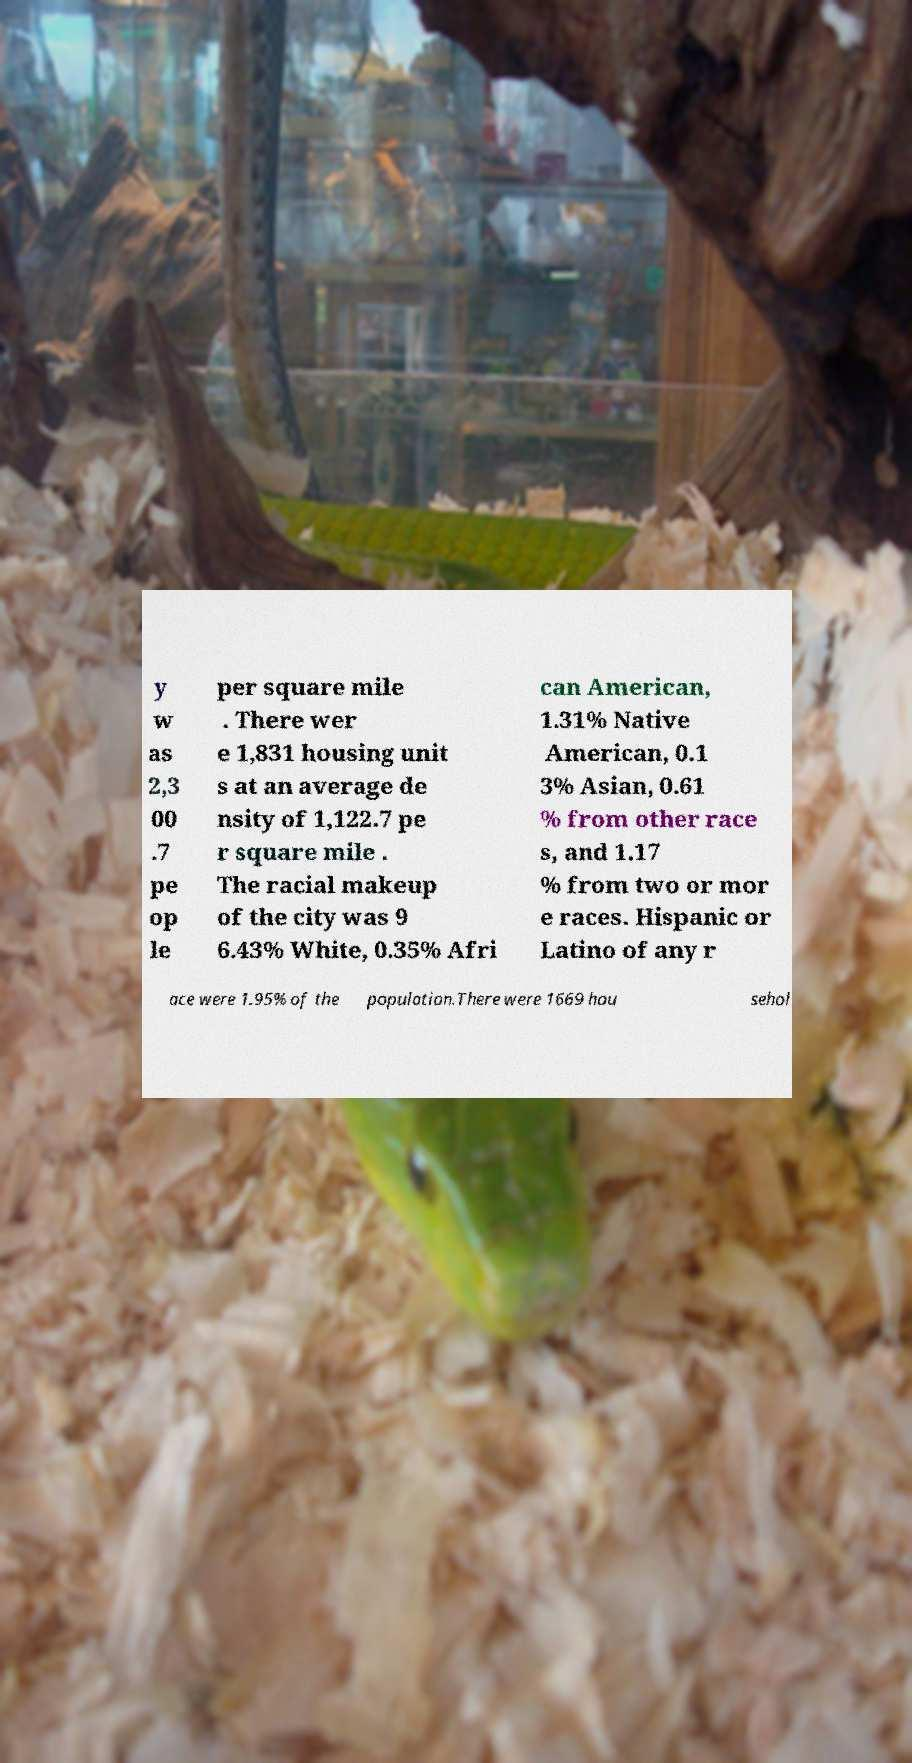Could you assist in decoding the text presented in this image and type it out clearly? y w as 2,3 00 .7 pe op le per square mile . There wer e 1,831 housing unit s at an average de nsity of 1,122.7 pe r square mile . The racial makeup of the city was 9 6.43% White, 0.35% Afri can American, 1.31% Native American, 0.1 3% Asian, 0.61 % from other race s, and 1.17 % from two or mor e races. Hispanic or Latino of any r ace were 1.95% of the population.There were 1669 hou sehol 